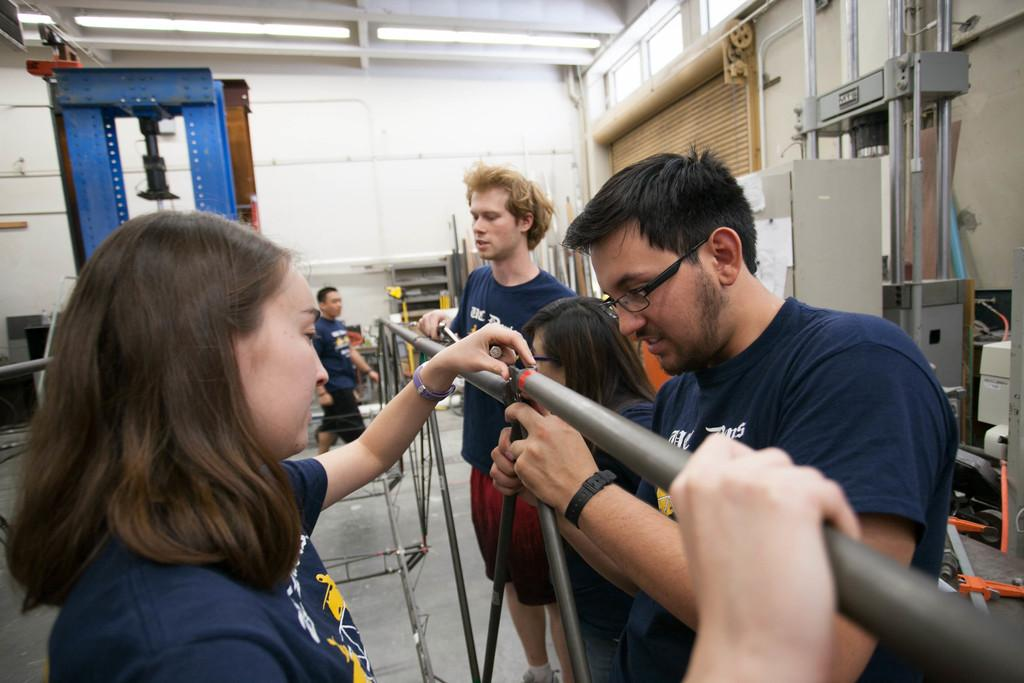Who or what is present in the image? There are people in the image. What objects can be seen in the image? There are rods in the image. What can be seen in the background of the image? There is a wall and some equipment visible in the background of the image. What type of fuel is being used by the boys in the image? There are no boys or fuel present in the image. How does the drain affect the people in the image? There is no drain present in the image. 